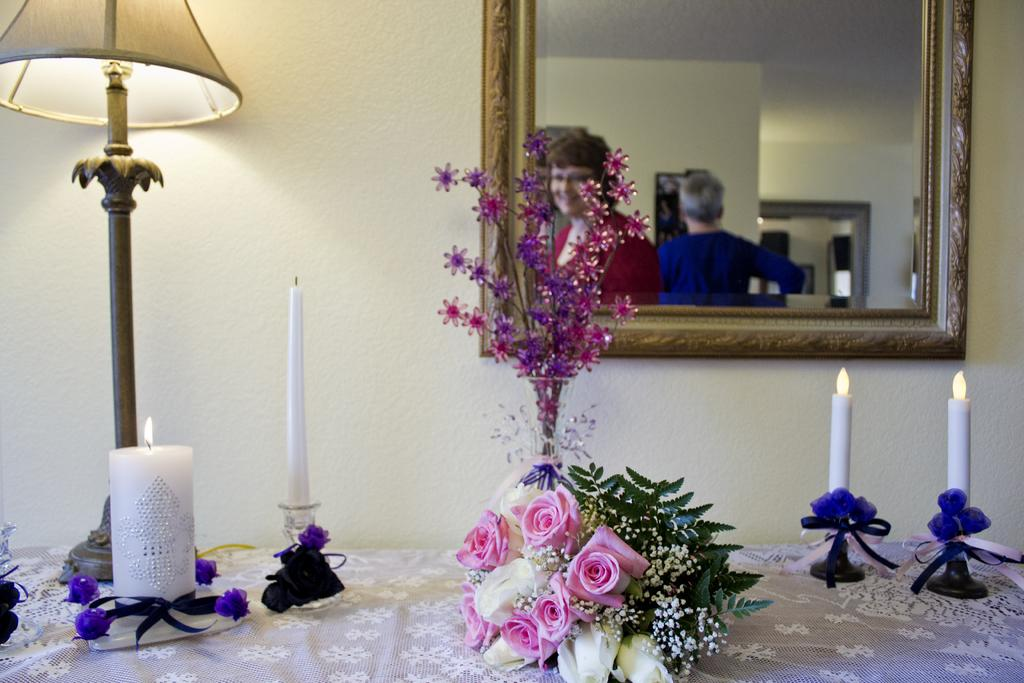What type of furniture is in the image? There is a table in the image. What decorative items can be seen on the table? Candles and a flower bouquet are present on the table. What is on the wall in the image? There is a mirror on the wall. What can be seen in the mirror's reflection? The mirror has a reflection of people in it. How does the stem of the flower bouquet contribute to reducing pollution in the image? The image does not mention any pollution or the stem of the flower bouquet, so it cannot be determined how it might contribute to reducing pollution. 